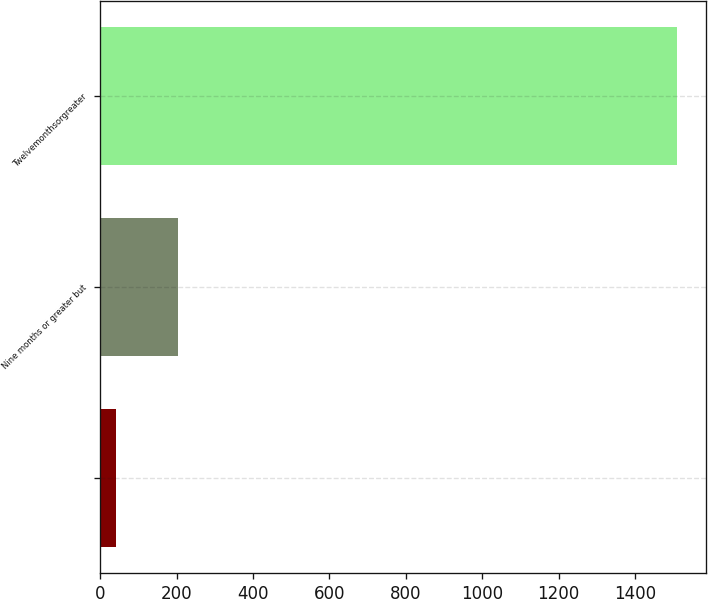Convert chart to OTSL. <chart><loc_0><loc_0><loc_500><loc_500><bar_chart><ecel><fcel>Nine months or greater but<fcel>Twelvemonthsorgreater<nl><fcel>42<fcel>204<fcel>1511<nl></chart> 